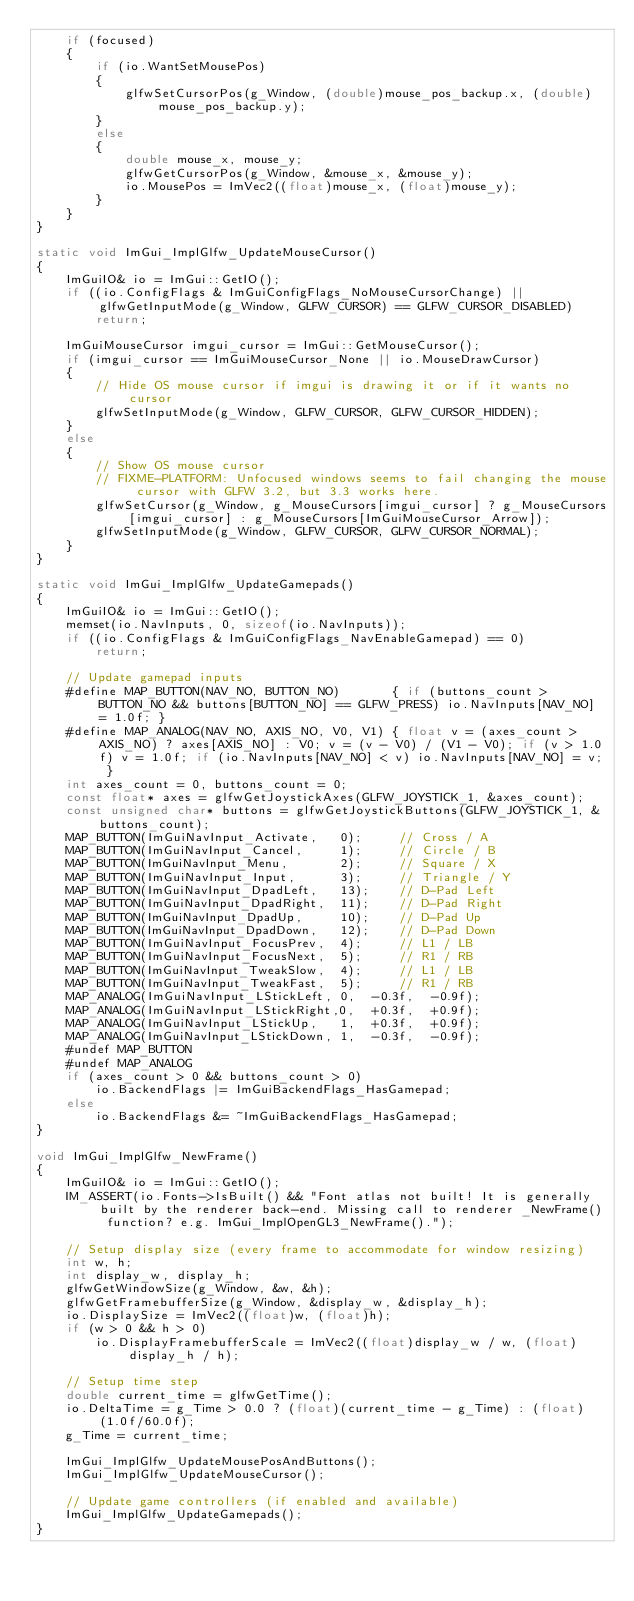<code> <loc_0><loc_0><loc_500><loc_500><_C++_>    if (focused)
    {
        if (io.WantSetMousePos)
        {
            glfwSetCursorPos(g_Window, (double)mouse_pos_backup.x, (double)mouse_pos_backup.y);
        }
        else
        {
            double mouse_x, mouse_y;
            glfwGetCursorPos(g_Window, &mouse_x, &mouse_y);
            io.MousePos = ImVec2((float)mouse_x, (float)mouse_y);
        }
    }
}

static void ImGui_ImplGlfw_UpdateMouseCursor()
{
    ImGuiIO& io = ImGui::GetIO();
    if ((io.ConfigFlags & ImGuiConfigFlags_NoMouseCursorChange) || glfwGetInputMode(g_Window, GLFW_CURSOR) == GLFW_CURSOR_DISABLED)
        return;

    ImGuiMouseCursor imgui_cursor = ImGui::GetMouseCursor();
    if (imgui_cursor == ImGuiMouseCursor_None || io.MouseDrawCursor)
    {
        // Hide OS mouse cursor if imgui is drawing it or if it wants no cursor
        glfwSetInputMode(g_Window, GLFW_CURSOR, GLFW_CURSOR_HIDDEN);
    }
    else
    {
        // Show OS mouse cursor
        // FIXME-PLATFORM: Unfocused windows seems to fail changing the mouse cursor with GLFW 3.2, but 3.3 works here.
        glfwSetCursor(g_Window, g_MouseCursors[imgui_cursor] ? g_MouseCursors[imgui_cursor] : g_MouseCursors[ImGuiMouseCursor_Arrow]);
        glfwSetInputMode(g_Window, GLFW_CURSOR, GLFW_CURSOR_NORMAL);
    }
}

static void ImGui_ImplGlfw_UpdateGamepads()
{
    ImGuiIO& io = ImGui::GetIO();
    memset(io.NavInputs, 0, sizeof(io.NavInputs));
    if ((io.ConfigFlags & ImGuiConfigFlags_NavEnableGamepad) == 0)
        return;

    // Update gamepad inputs
    #define MAP_BUTTON(NAV_NO, BUTTON_NO)       { if (buttons_count > BUTTON_NO && buttons[BUTTON_NO] == GLFW_PRESS) io.NavInputs[NAV_NO] = 1.0f; }
    #define MAP_ANALOG(NAV_NO, AXIS_NO, V0, V1) { float v = (axes_count > AXIS_NO) ? axes[AXIS_NO] : V0; v = (v - V0) / (V1 - V0); if (v > 1.0f) v = 1.0f; if (io.NavInputs[NAV_NO] < v) io.NavInputs[NAV_NO] = v; }
    int axes_count = 0, buttons_count = 0;
    const float* axes = glfwGetJoystickAxes(GLFW_JOYSTICK_1, &axes_count);
    const unsigned char* buttons = glfwGetJoystickButtons(GLFW_JOYSTICK_1, &buttons_count);
    MAP_BUTTON(ImGuiNavInput_Activate,   0);     // Cross / A
    MAP_BUTTON(ImGuiNavInput_Cancel,     1);     // Circle / B
    MAP_BUTTON(ImGuiNavInput_Menu,       2);     // Square / X
    MAP_BUTTON(ImGuiNavInput_Input,      3);     // Triangle / Y
    MAP_BUTTON(ImGuiNavInput_DpadLeft,   13);    // D-Pad Left
    MAP_BUTTON(ImGuiNavInput_DpadRight,  11);    // D-Pad Right
    MAP_BUTTON(ImGuiNavInput_DpadUp,     10);    // D-Pad Up
    MAP_BUTTON(ImGuiNavInput_DpadDown,   12);    // D-Pad Down
    MAP_BUTTON(ImGuiNavInput_FocusPrev,  4);     // L1 / LB
    MAP_BUTTON(ImGuiNavInput_FocusNext,  5);     // R1 / RB
    MAP_BUTTON(ImGuiNavInput_TweakSlow,  4);     // L1 / LB
    MAP_BUTTON(ImGuiNavInput_TweakFast,  5);     // R1 / RB
    MAP_ANALOG(ImGuiNavInput_LStickLeft, 0,  -0.3f,  -0.9f);
    MAP_ANALOG(ImGuiNavInput_LStickRight,0,  +0.3f,  +0.9f);
    MAP_ANALOG(ImGuiNavInput_LStickUp,   1,  +0.3f,  +0.9f);
    MAP_ANALOG(ImGuiNavInput_LStickDown, 1,  -0.3f,  -0.9f);
    #undef MAP_BUTTON
    #undef MAP_ANALOG
    if (axes_count > 0 && buttons_count > 0)
        io.BackendFlags |= ImGuiBackendFlags_HasGamepad;
    else
        io.BackendFlags &= ~ImGuiBackendFlags_HasGamepad;
}

void ImGui_ImplGlfw_NewFrame()
{
    ImGuiIO& io = ImGui::GetIO();
    IM_ASSERT(io.Fonts->IsBuilt() && "Font atlas not built! It is generally built by the renderer back-end. Missing call to renderer _NewFrame() function? e.g. ImGui_ImplOpenGL3_NewFrame().");

    // Setup display size (every frame to accommodate for window resizing)
    int w, h;
    int display_w, display_h;
    glfwGetWindowSize(g_Window, &w, &h);
    glfwGetFramebufferSize(g_Window, &display_w, &display_h);
    io.DisplaySize = ImVec2((float)w, (float)h);
    if (w > 0 && h > 0)
        io.DisplayFramebufferScale = ImVec2((float)display_w / w, (float)display_h / h);

    // Setup time step
    double current_time = glfwGetTime();
    io.DeltaTime = g_Time > 0.0 ? (float)(current_time - g_Time) : (float)(1.0f/60.0f);
    g_Time = current_time;

    ImGui_ImplGlfw_UpdateMousePosAndButtons();
    ImGui_ImplGlfw_UpdateMouseCursor();

    // Update game controllers (if enabled and available)
    ImGui_ImplGlfw_UpdateGamepads();
}
</code> 